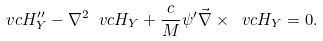<formula> <loc_0><loc_0><loc_500><loc_500>\ v c H _ { Y } ^ { \prime \prime } - \nabla ^ { 2 } \ v c H _ { Y } + \frac { c } { M } \psi ^ { \prime } \vec { \nabla } \times \ v c H _ { Y } = 0 .</formula> 